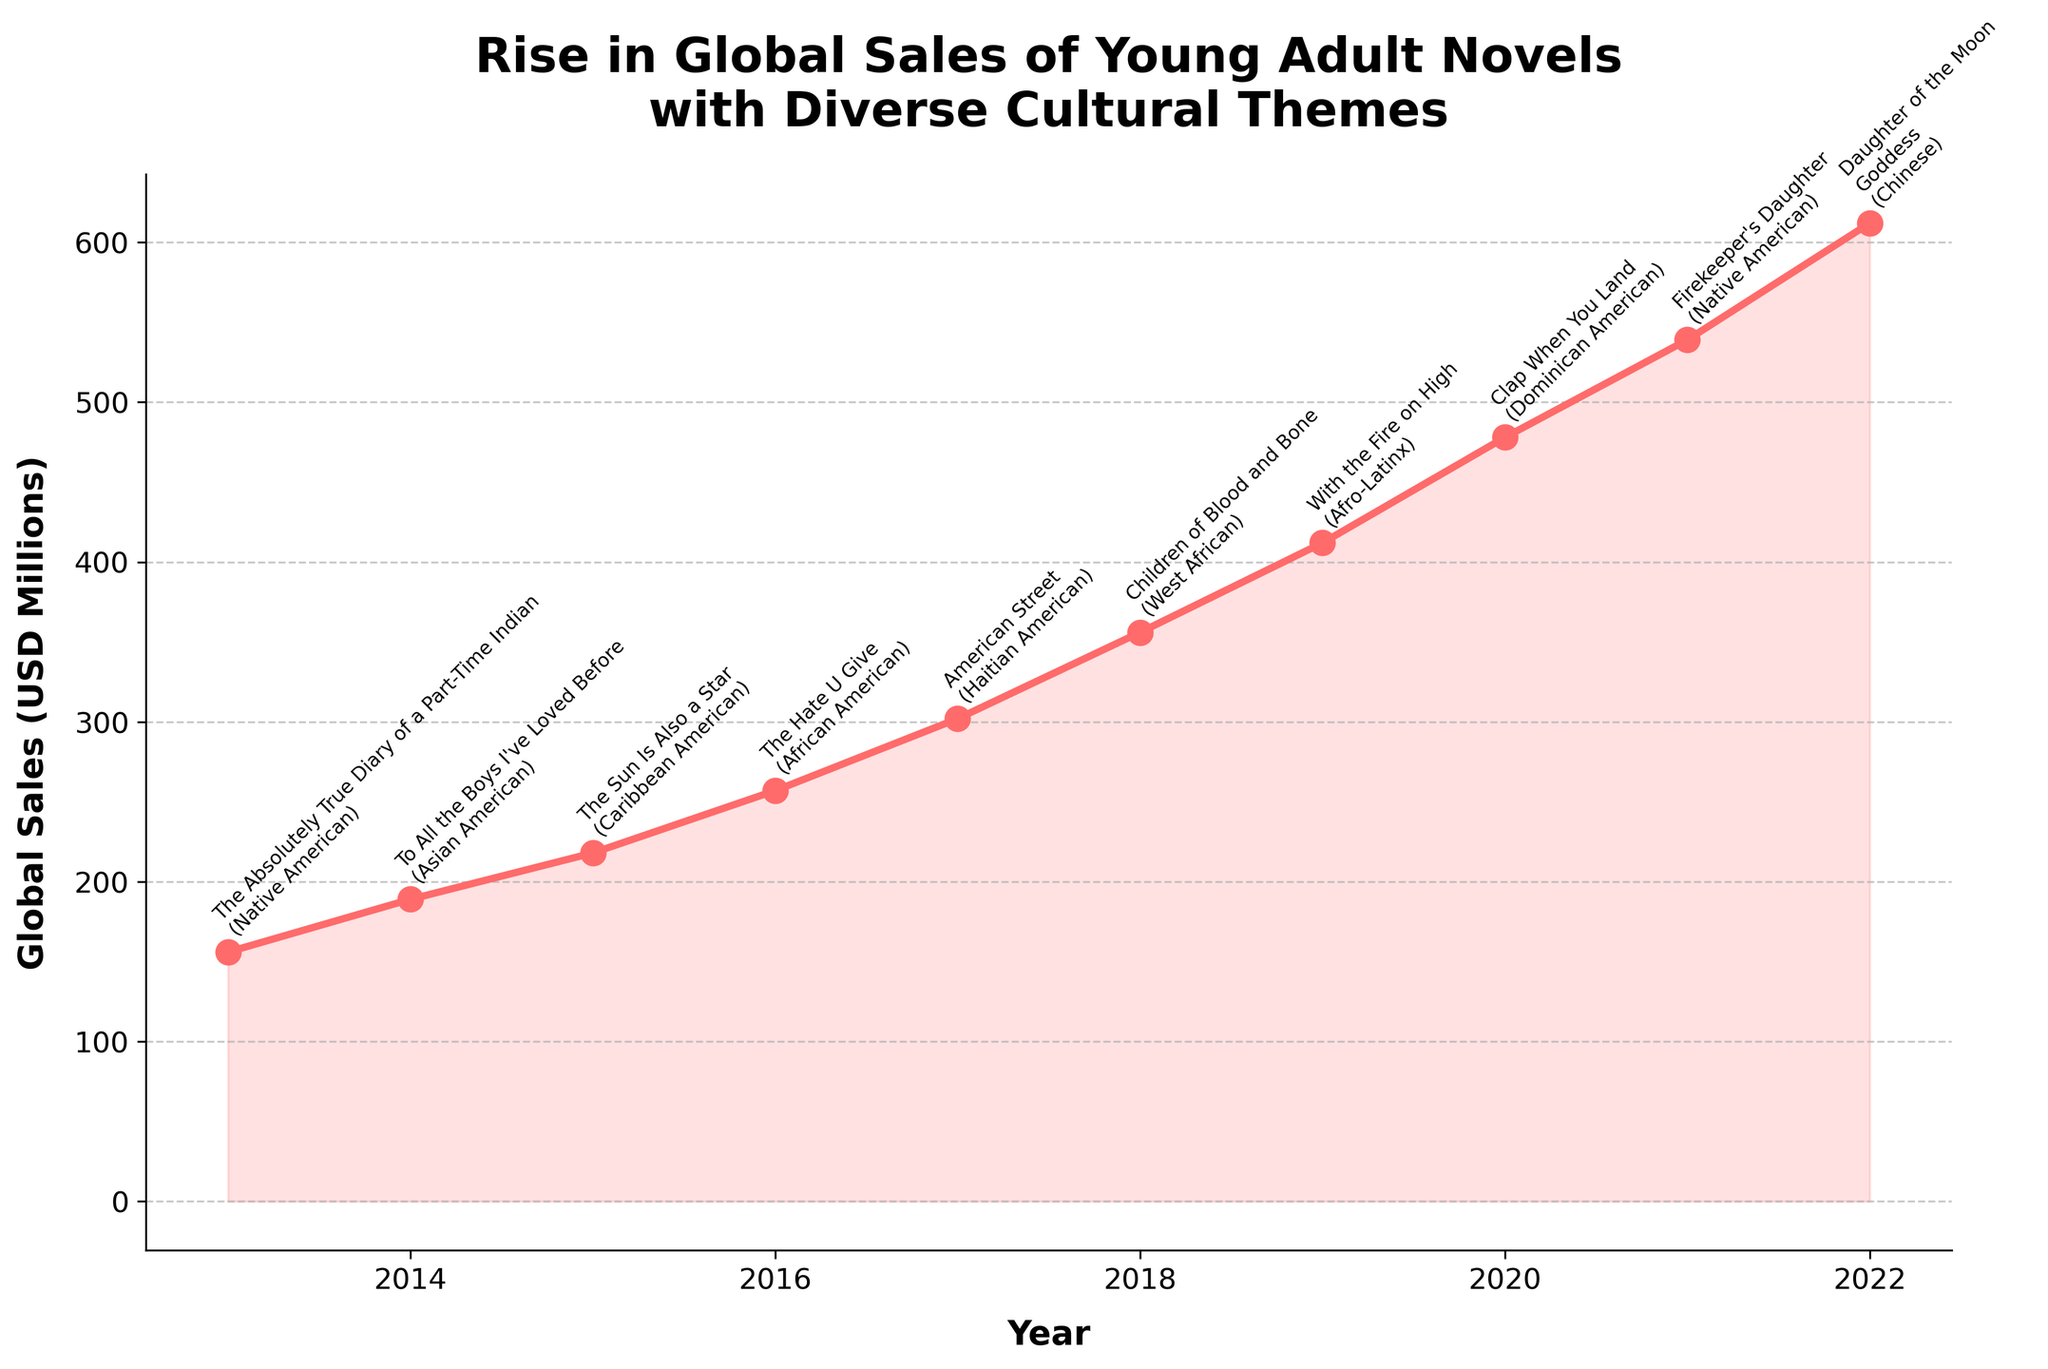Which year saw the highest global sales for young adult novels with diverse cultural themes? To find the highest global sales, locate the year with the tallest point on the chart. The peak is at 2022 with sales of 612 million USD.
Answer: 2022 What was the increase in global sales from 2013 to 2022? First, find the sales for 2013, which is 156 million USD, and for 2022, which is 612 million USD. Subtract 156 from 612 to get the difference.
Answer: 456 million USD Which year experienced the largest single-year increase in sales, and by how much? To find the largest single-year increase, calculate the difference between consecutive years and find the maximum. The largest increase occurs between 2019 (412 million USD) and 2020 (478 million USD), giving an increase of 66 million USD.
Answer: 2019-2020, 66 million USD What is the average annual global sales across the decade? To find the average, sum the sales from each year (156 + 189 + 218 + 257 + 302 + 356 + 412 + 478 + 539 + 612 = 3519 million USD) and divide by the number of years (10).
Answer: 351.9 million USD Which book with a Caribbean American cultural theme had the highest sales, and in what year? Look for the top-selling title with a Caribbean American theme and the corresponding year. "The Sun Is Also a Star" in 2015 is the relevant data.
Answer: "The Sun Is Also a Star", 2015 Between which consecutive years did sales remain most stable, i.e., have the smallest change in sales? Calculate the sales difference between consecutive years and find the smallest difference. The smallest change is between 2021 (539 million USD) and 2022 (612 million USD), which is a difference of 73 million USD.
Answer: 2021-2022 Which year's top-selling book had a West African cultural theme, and how much were the global sales that year? Identify the book with a West African cultural theme and the corresponding year. "Children of Blood and Bone" was the top-selling book in 2018, with sales of 356 million USD.
Answer: 2018, 356 million USD Compare the global sales in 2014 and 2016. Which year had higher sales, and by how much? Compare the sales figures for 2014 (189 million USD) and 2016 (257 million USD). Subtract the smaller from the larger to find the difference.
Answer: 2016, 68 million USD Which two consecutive years had the highest combined sales and what was the combined amount? Calculate the combined sales for each pair of consecutive years and identify the highest total. The years 2021 (539 million USD) and 2022 (612 million USD) have the highest combined sales of 1151 million USD.
Answer: 2021-2022, 1151 million USD 